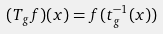<formula> <loc_0><loc_0><loc_500><loc_500>( T _ { g } f ) ( x ) = f ( t ^ { - 1 } _ { g } ( x ) )</formula> 